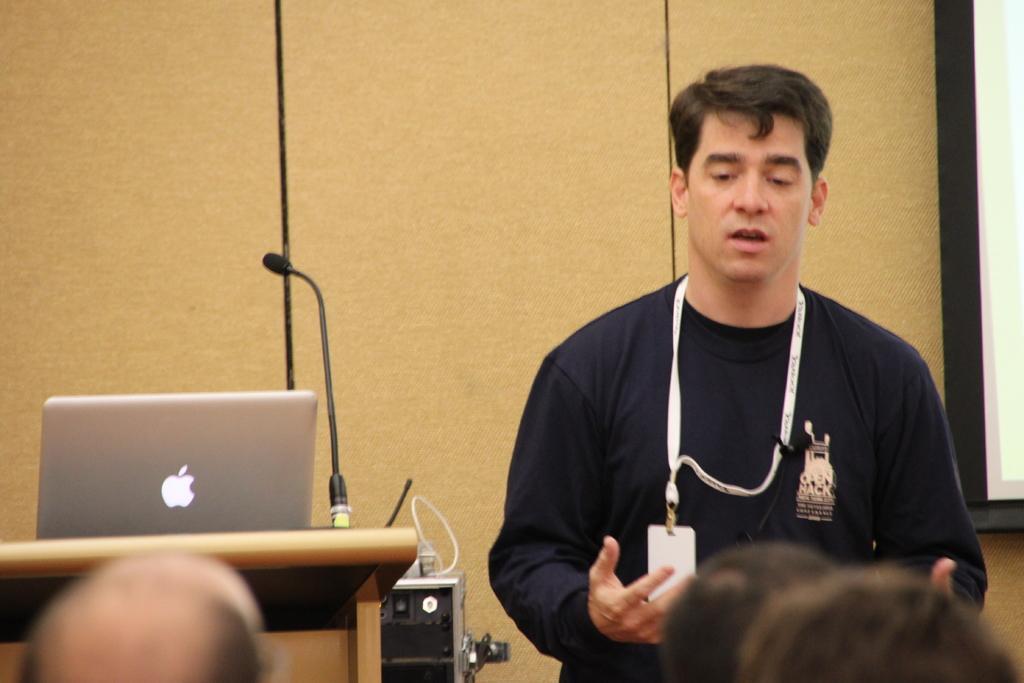Can you describe this image briefly? A man is standing and talking, he wore t-shirt, Id card. On the left side there is a laptop and a microphone. 